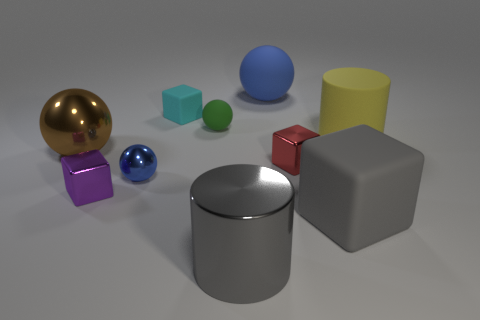How many tiny cyan things have the same shape as the red object?
Provide a short and direct response. 1. There is a brown object that is the same material as the tiny blue sphere; what is its size?
Your response must be concise. Large. Are there more brown matte objects than yellow cylinders?
Keep it short and to the point. No. There is a large object that is to the left of the cyan matte block; what is its color?
Your answer should be very brief. Brown. What size is the block that is in front of the brown metal object and on the left side of the small red cube?
Offer a terse response. Small. How many metallic blocks are the same size as the rubber cylinder?
Provide a succinct answer. 0. What material is the big gray thing that is the same shape as the tiny red object?
Offer a terse response. Rubber. Is the red object the same shape as the big gray rubber thing?
Make the answer very short. Yes. What number of blue things are in front of the large blue rubber sphere?
Provide a succinct answer. 1. There is a large gray thing that is in front of the rubber object that is in front of the blue metal object; what shape is it?
Give a very brief answer. Cylinder. 